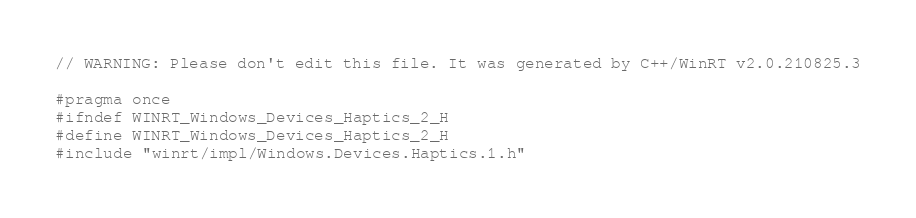Convert code to text. <code><loc_0><loc_0><loc_500><loc_500><_C_>// WARNING: Please don't edit this file. It was generated by C++/WinRT v2.0.210825.3

#pragma once
#ifndef WINRT_Windows_Devices_Haptics_2_H
#define WINRT_Windows_Devices_Haptics_2_H
#include "winrt/impl/Windows.Devices.Haptics.1.h"</code> 